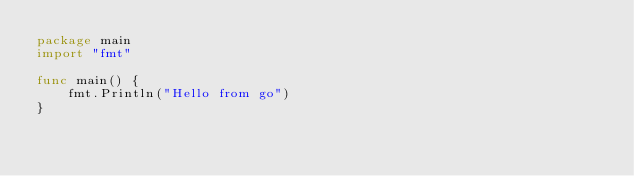Convert code to text. <code><loc_0><loc_0><loc_500><loc_500><_Go_>package main
import "fmt"

func main() {
	fmt.Println("Hello from go")
}
</code> 